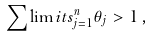<formula> <loc_0><loc_0><loc_500><loc_500>\sum \lim i t s _ { j = 1 } ^ { n } \theta _ { j } > 1 \, ,</formula> 